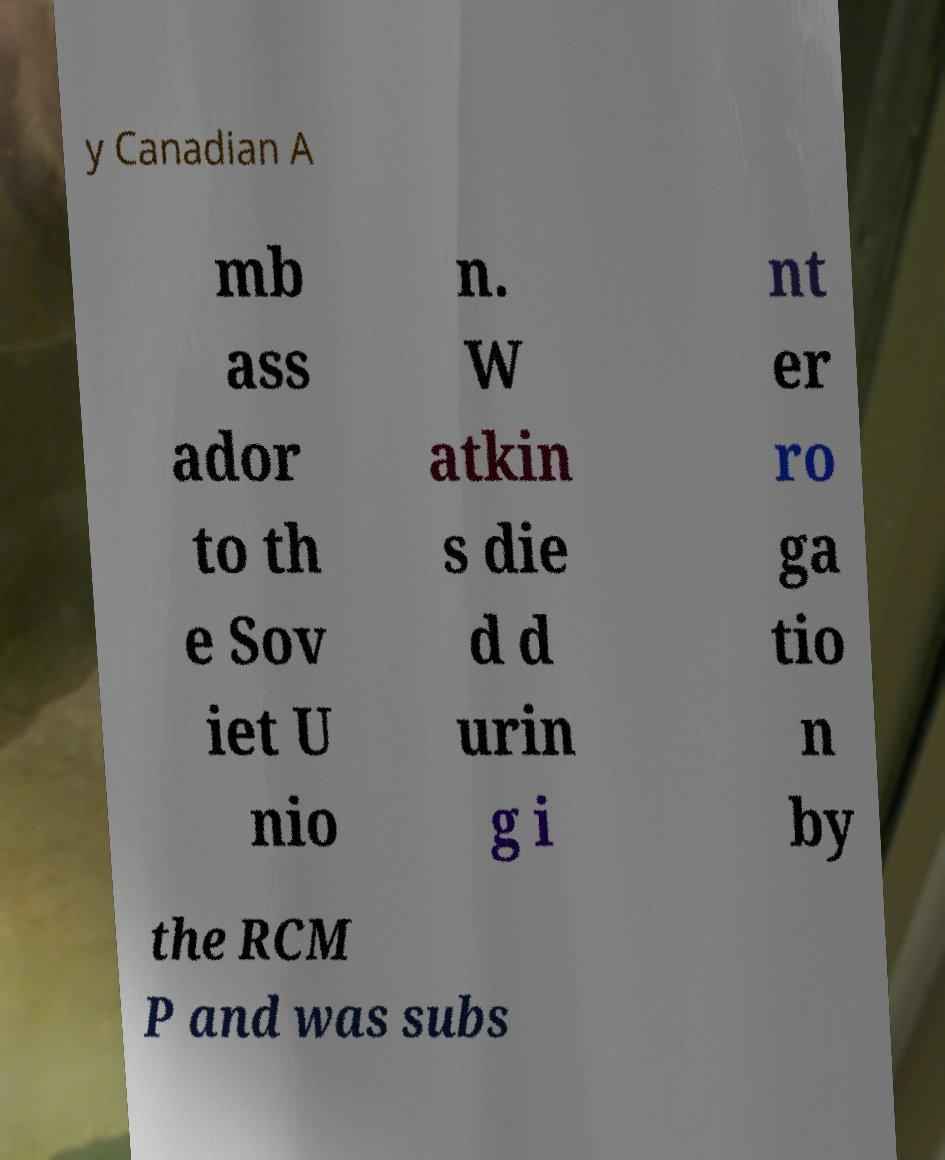Can you accurately transcribe the text from the provided image for me? y Canadian A mb ass ador to th e Sov iet U nio n. W atkin s die d d urin g i nt er ro ga tio n by the RCM P and was subs 